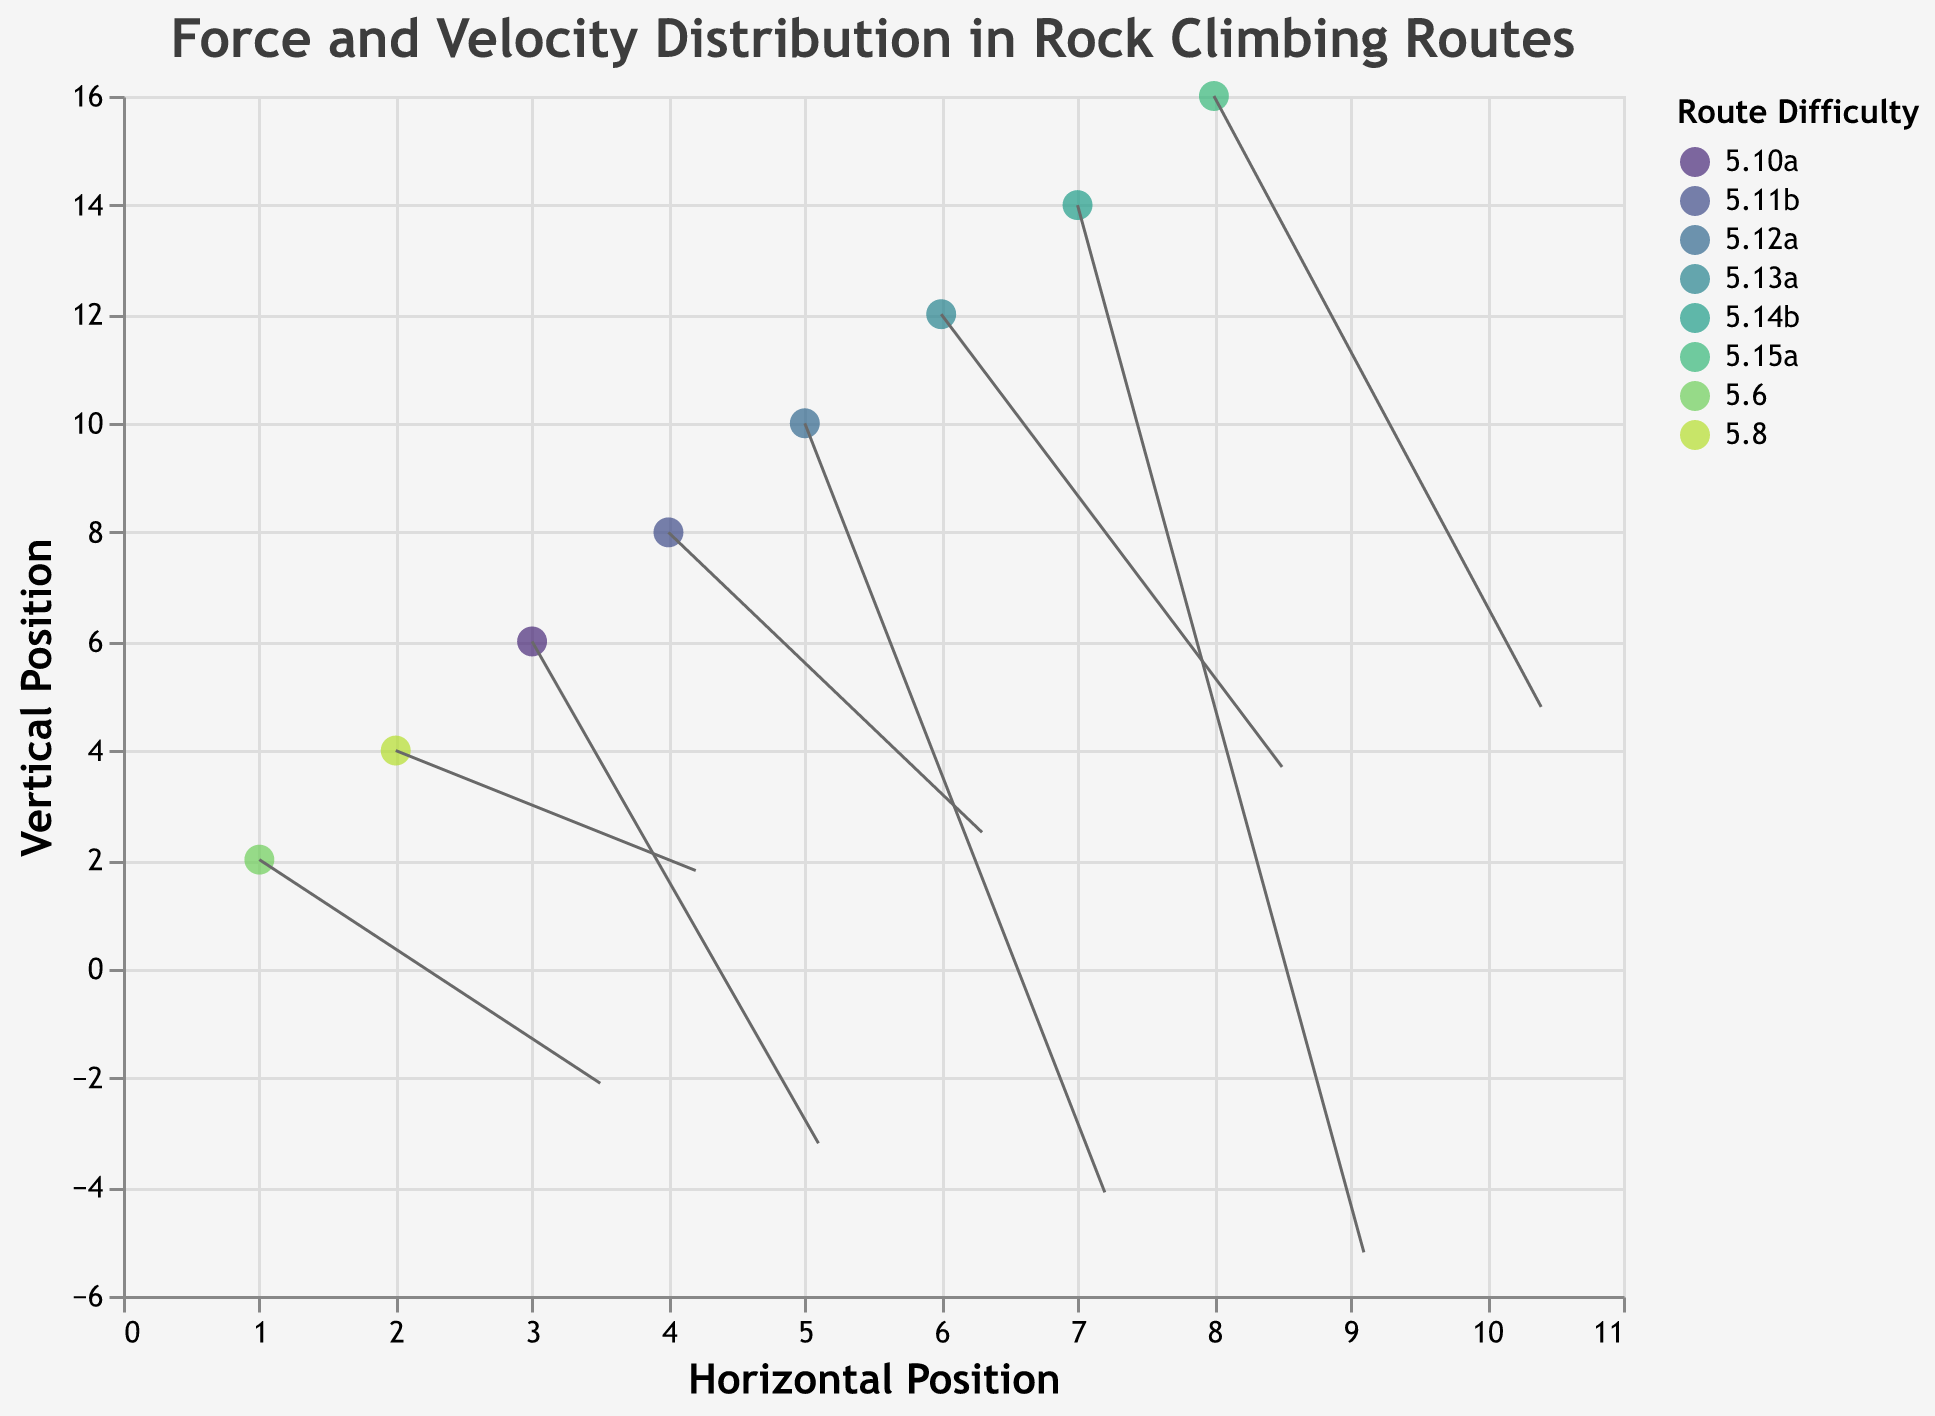What's the title of the plot? The title is always placed at the top of the chart and in this case, it reads: "Force and Velocity Distribution in Rock Climbing Routes".
Answer: Force and Velocity Distribution in Rock Climbing Routes How many total data points are represented in the plot? The data table shows eight different rows of points, each representing a unique climbing route.
Answer: 8 Which climbing route has the highest difficulty? By visually inspecting the legend and matching colors and route names, "Gravity Defier" has the highest difficulty labeled as 5.15a.
Answer: Gravity Defier What are the horizontal and vertical position values for "Corn Maze Crusher"? We can find the position values by identifying the point corresponding to "Corn Maze Crusher" in the tooltip or data table, showing (x, y) = (5, 10).
Answer: (5, 10) Which route has the largest horizontal force (u) and what's its value? The largest horizontal force can be found by comparing the u-values plotted on the chart, which shows "Gravity Defier" having u = 10.4.
Answer: Gravity Defier with u = 10.4 Which route shows a negative vertical force (v), and what's its value? By inspecting the quivers, "Extreme Overhang" exhibits a vertical force v = -5.2.
Answer: Extreme Overhang with v = -5.2 Are there more routes experiencing upward or downward velocities (v-values)? Comparing v-values of each quiver, there are 4 upward (positive) and 4 downward (negative) velocities.
Answer: Equal number of upward and downward velocities On average, are the forces (u-values) greater in magnitude in more difficult routes compared to easier ones? Visually inspect and average the u-values for routes grouped by difficulty level. Calculate: Average of easier routes (5.6 to 5.10a) => (3.5 + 4.2 + 5.1)/3 = 4.27; Average of more difficult routes (5.11b to 5.15a) => (6.3 + 7.2 + 8.5 + 9.1 + 10.4)/5 = 8.3.
Answer: Yes Which route has the largest force vector (u*v) in magnitude? Calculate the magnitude of the force vector for each route (u*v) and compare. Gravity Defier's force vector: 10.4 * 4.8 = 49.92, highest among others.
Answer: Gravity Defier 